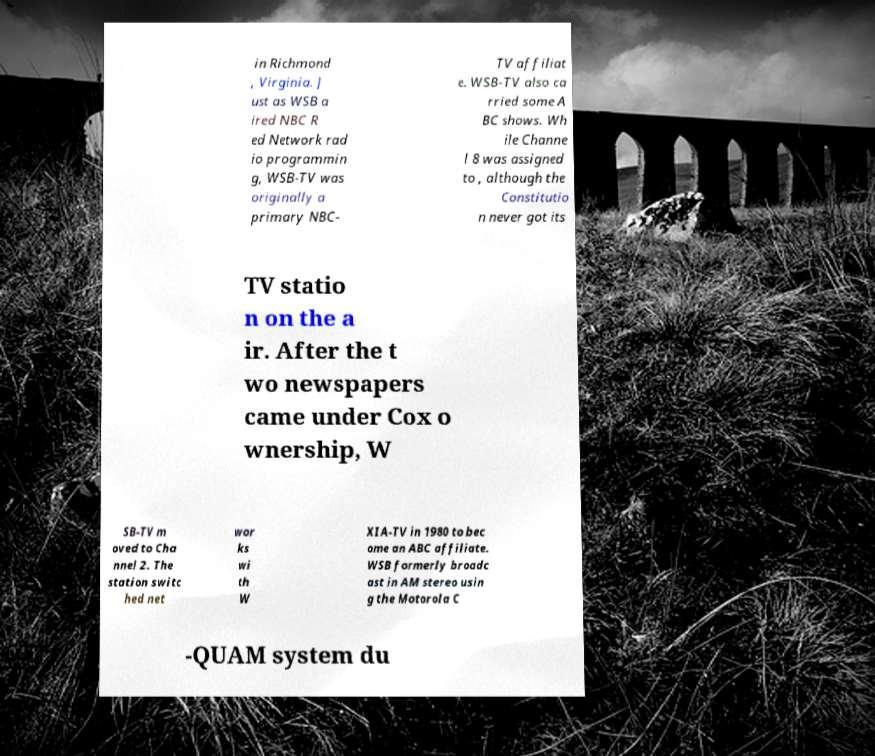For documentation purposes, I need the text within this image transcribed. Could you provide that? in Richmond , Virginia. J ust as WSB a ired NBC R ed Network rad io programmin g, WSB-TV was originally a primary NBC- TV affiliat e. WSB-TV also ca rried some A BC shows. Wh ile Channe l 8 was assigned to , although the Constitutio n never got its TV statio n on the a ir. After the t wo newspapers came under Cox o wnership, W SB-TV m oved to Cha nnel 2. The station switc hed net wor ks wi th W XIA-TV in 1980 to bec ome an ABC affiliate. WSB formerly broadc ast in AM stereo usin g the Motorola C -QUAM system du 